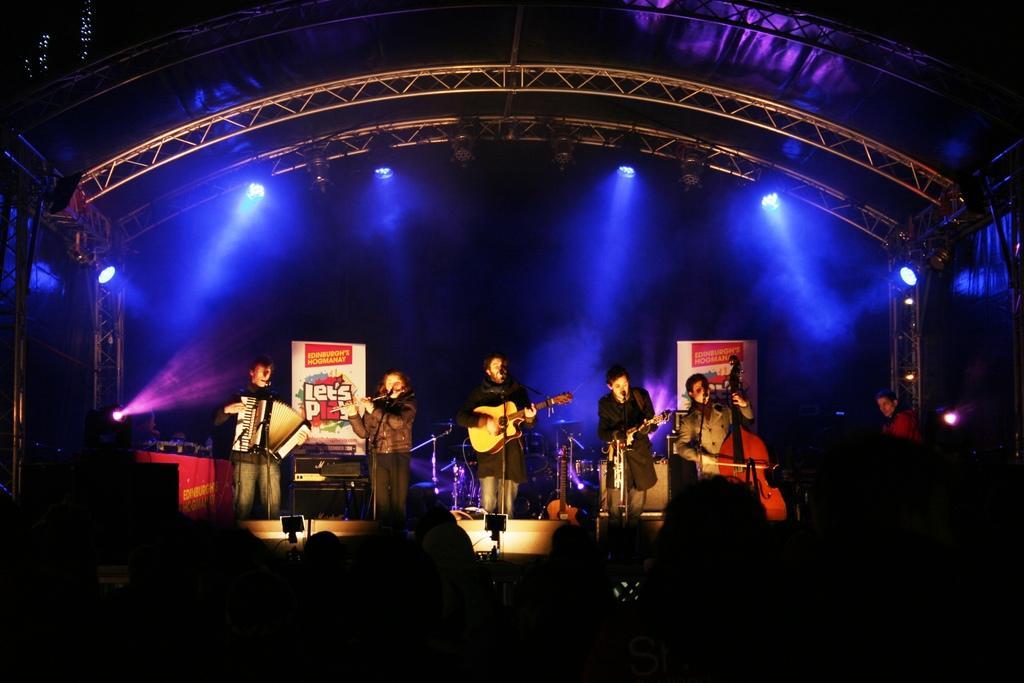Please provide a concise description of this image. In this picture we can see there is a group of people holding the musical instruments and standing on a stage. Behind the people, there are some music systems and boards. At the top of the image, there are lights and trusses. 